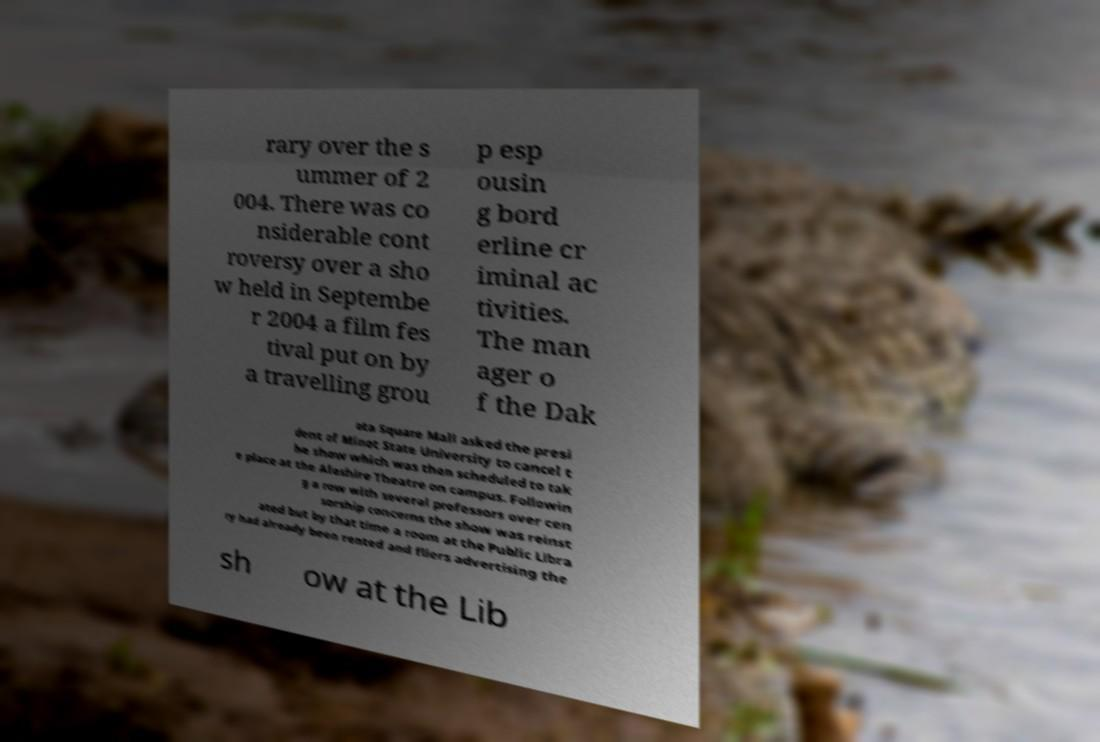Could you assist in decoding the text presented in this image and type it out clearly? rary over the s ummer of 2 004. There was co nsiderable cont roversy over a sho w held in Septembe r 2004 a film fes tival put on by a travelling grou p esp ousin g bord erline cr iminal ac tivities. The man ager o f the Dak ota Square Mall asked the presi dent of Minot State University to cancel t he show which was then scheduled to tak e place at the Aleshire Theatre on campus. Followin g a row with several professors over cen sorship concerns the show was reinst ated but by that time a room at the Public Libra ry had already been rented and fliers advertising the sh ow at the Lib 